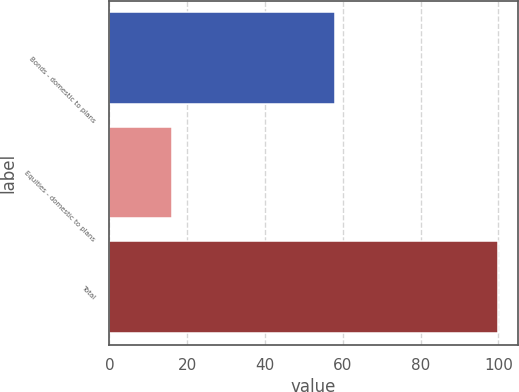Convert chart. <chart><loc_0><loc_0><loc_500><loc_500><bar_chart><fcel>Bonds - domestic to plans<fcel>Equities - domestic to plans<fcel>Total<nl><fcel>58<fcel>16<fcel>100<nl></chart> 